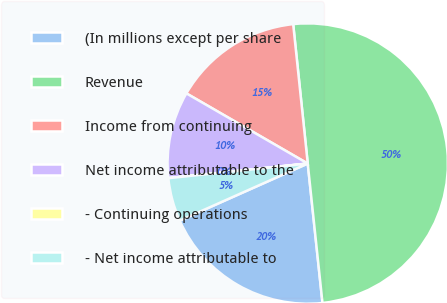<chart> <loc_0><loc_0><loc_500><loc_500><pie_chart><fcel>(In millions except per share<fcel>Revenue<fcel>Income from continuing<fcel>Net income attributable to the<fcel>- Continuing operations<fcel>- Net income attributable to<nl><fcel>20.0%<fcel>49.98%<fcel>15.0%<fcel>10.0%<fcel>0.01%<fcel>5.01%<nl></chart> 